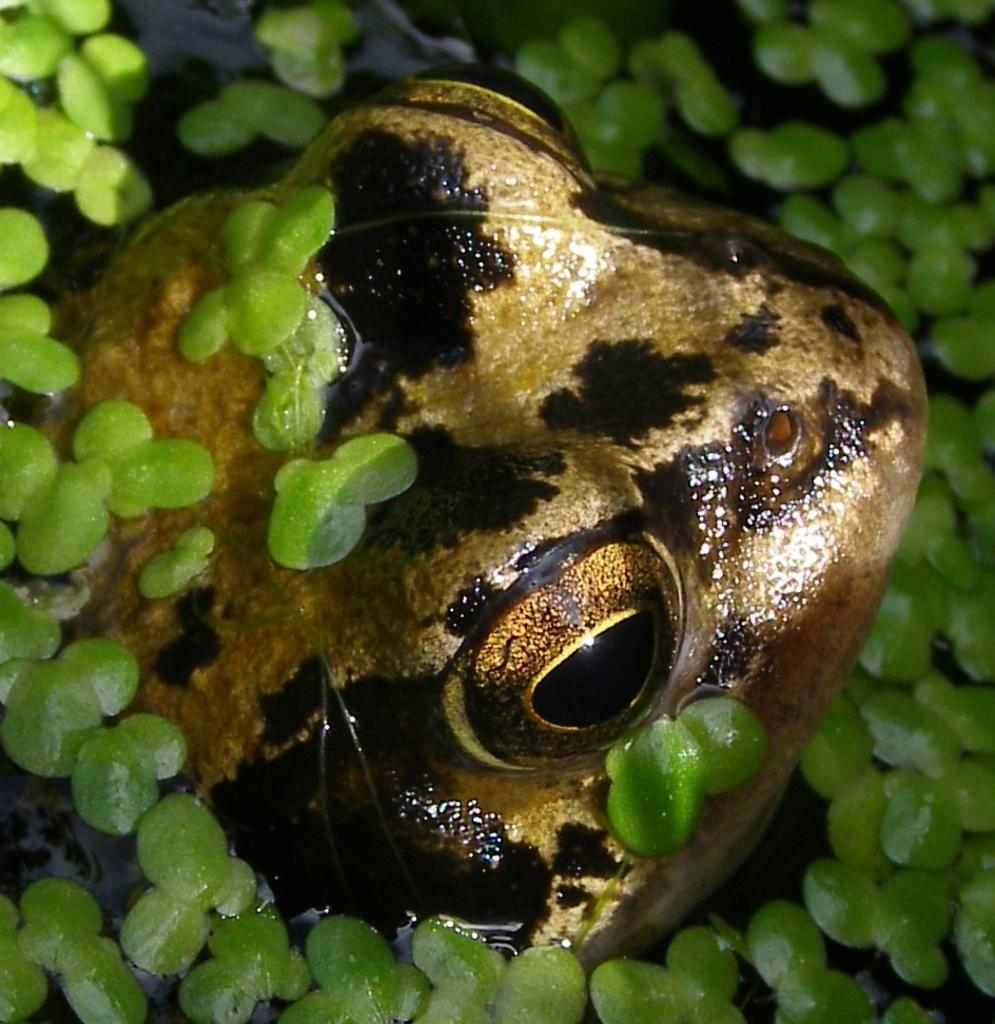What type of living creature is present in the image? There is an animal in the image. What can be seen in the background or surrounding the animal? There are leaves in the image. What type of guitar is the governor playing in the image? There is no guitar or governor present in the image; it only features an animal and leaves. 